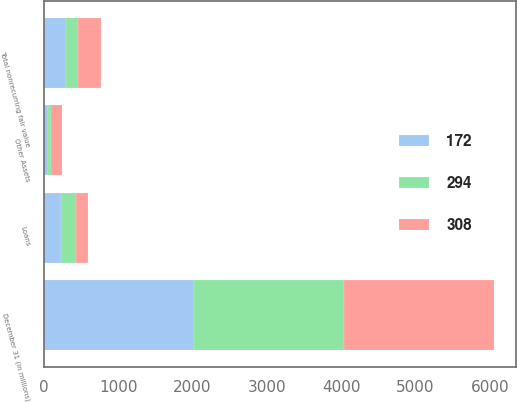Convert chart to OTSL. <chart><loc_0><loc_0><loc_500><loc_500><stacked_bar_chart><ecel><fcel>December 31 (in millions)<fcel>Loans<fcel>Other Assets<fcel>Total nonrecurring fair value<nl><fcel>308<fcel>2017<fcel>159<fcel>148<fcel>308<nl><fcel>294<fcel>2016<fcel>209<fcel>37<fcel>172<nl><fcel>172<fcel>2015<fcel>226<fcel>60<fcel>294<nl></chart> 